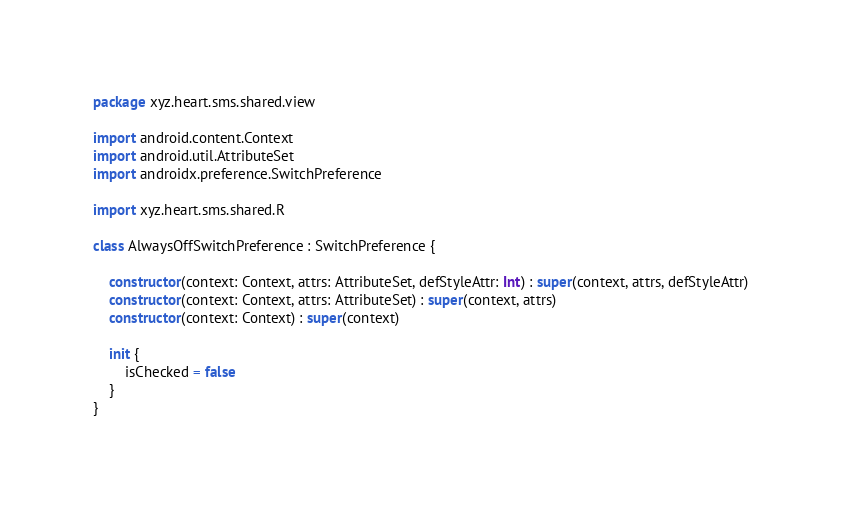<code> <loc_0><loc_0><loc_500><loc_500><_Kotlin_>package xyz.heart.sms.shared.view

import android.content.Context
import android.util.AttributeSet
import androidx.preference.SwitchPreference

import xyz.heart.sms.shared.R

class AlwaysOffSwitchPreference : SwitchPreference {

    constructor(context: Context, attrs: AttributeSet, defStyleAttr: Int) : super(context, attrs, defStyleAttr)
    constructor(context: Context, attrs: AttributeSet) : super(context, attrs)
    constructor(context: Context) : super(context)

    init {
        isChecked = false
    }
}
</code> 